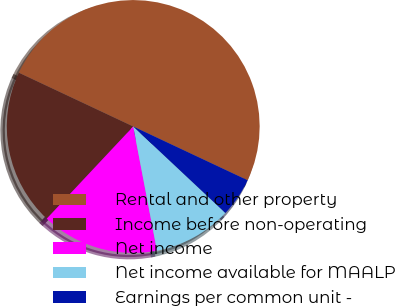Convert chart. <chart><loc_0><loc_0><loc_500><loc_500><pie_chart><fcel>Rental and other property<fcel>Income before non-operating<fcel>Net income<fcel>Net income available for MAALP<fcel>Earnings per common unit -<nl><fcel>50.0%<fcel>20.0%<fcel>15.0%<fcel>10.0%<fcel>5.0%<nl></chart> 